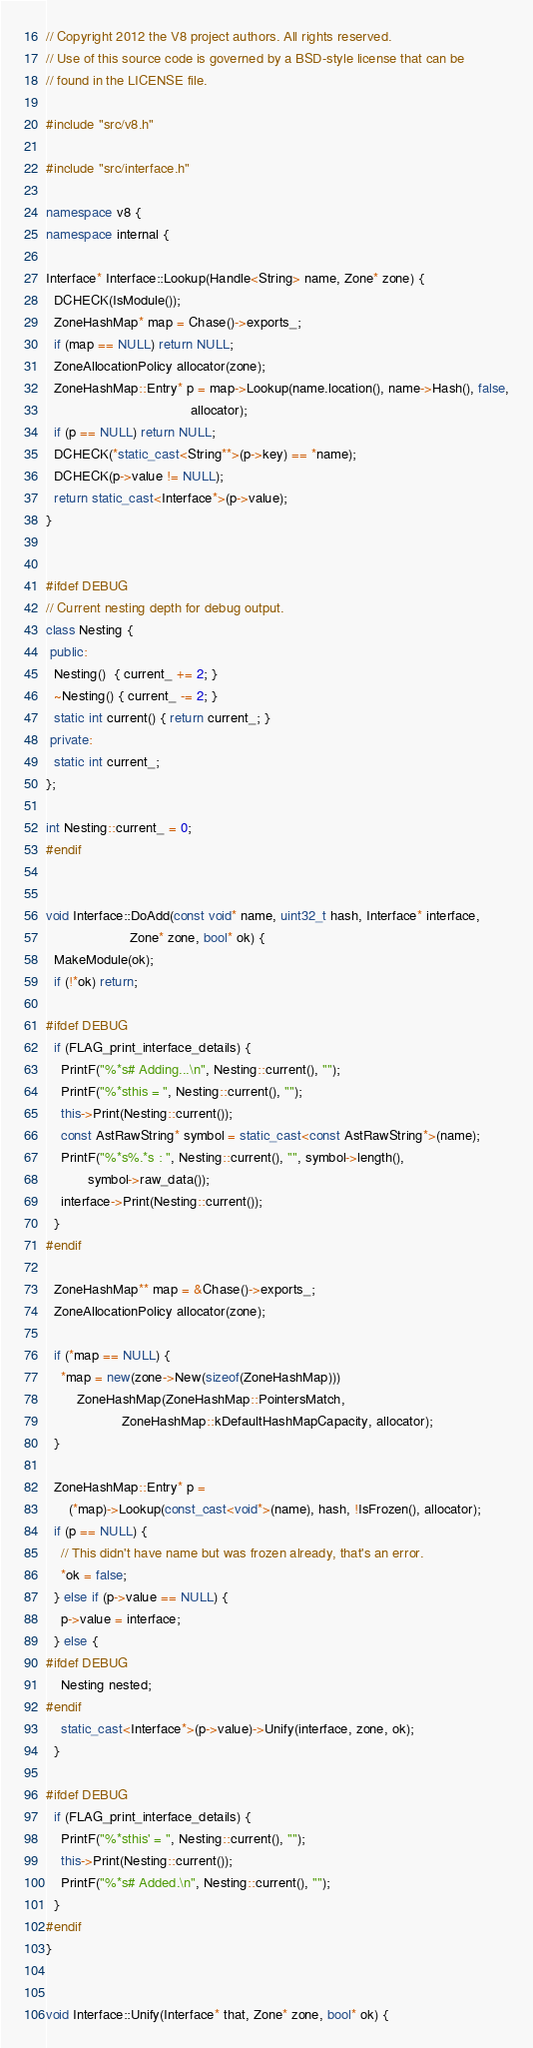<code> <loc_0><loc_0><loc_500><loc_500><_C++_>// Copyright 2012 the V8 project authors. All rights reserved.
// Use of this source code is governed by a BSD-style license that can be
// found in the LICENSE file.

#include "src/v8.h"

#include "src/interface.h"

namespace v8 {
namespace internal {

Interface* Interface::Lookup(Handle<String> name, Zone* zone) {
  DCHECK(IsModule());
  ZoneHashMap* map = Chase()->exports_;
  if (map == NULL) return NULL;
  ZoneAllocationPolicy allocator(zone);
  ZoneHashMap::Entry* p = map->Lookup(name.location(), name->Hash(), false,
                                      allocator);
  if (p == NULL) return NULL;
  DCHECK(*static_cast<String**>(p->key) == *name);
  DCHECK(p->value != NULL);
  return static_cast<Interface*>(p->value);
}


#ifdef DEBUG
// Current nesting depth for debug output.
class Nesting {
 public:
  Nesting()  { current_ += 2; }
  ~Nesting() { current_ -= 2; }
  static int current() { return current_; }
 private:
  static int current_;
};

int Nesting::current_ = 0;
#endif


void Interface::DoAdd(const void* name, uint32_t hash, Interface* interface,
                      Zone* zone, bool* ok) {
  MakeModule(ok);
  if (!*ok) return;

#ifdef DEBUG
  if (FLAG_print_interface_details) {
    PrintF("%*s# Adding...\n", Nesting::current(), "");
    PrintF("%*sthis = ", Nesting::current(), "");
    this->Print(Nesting::current());
    const AstRawString* symbol = static_cast<const AstRawString*>(name);
    PrintF("%*s%.*s : ", Nesting::current(), "", symbol->length(),
           symbol->raw_data());
    interface->Print(Nesting::current());
  }
#endif

  ZoneHashMap** map = &Chase()->exports_;
  ZoneAllocationPolicy allocator(zone);

  if (*map == NULL) {
    *map = new(zone->New(sizeof(ZoneHashMap)))
        ZoneHashMap(ZoneHashMap::PointersMatch,
                    ZoneHashMap::kDefaultHashMapCapacity, allocator);
  }

  ZoneHashMap::Entry* p =
      (*map)->Lookup(const_cast<void*>(name), hash, !IsFrozen(), allocator);
  if (p == NULL) {
    // This didn't have name but was frozen already, that's an error.
    *ok = false;
  } else if (p->value == NULL) {
    p->value = interface;
  } else {
#ifdef DEBUG
    Nesting nested;
#endif
    static_cast<Interface*>(p->value)->Unify(interface, zone, ok);
  }

#ifdef DEBUG
  if (FLAG_print_interface_details) {
    PrintF("%*sthis' = ", Nesting::current(), "");
    this->Print(Nesting::current());
    PrintF("%*s# Added.\n", Nesting::current(), "");
  }
#endif
}


void Interface::Unify(Interface* that, Zone* zone, bool* ok) {</code> 